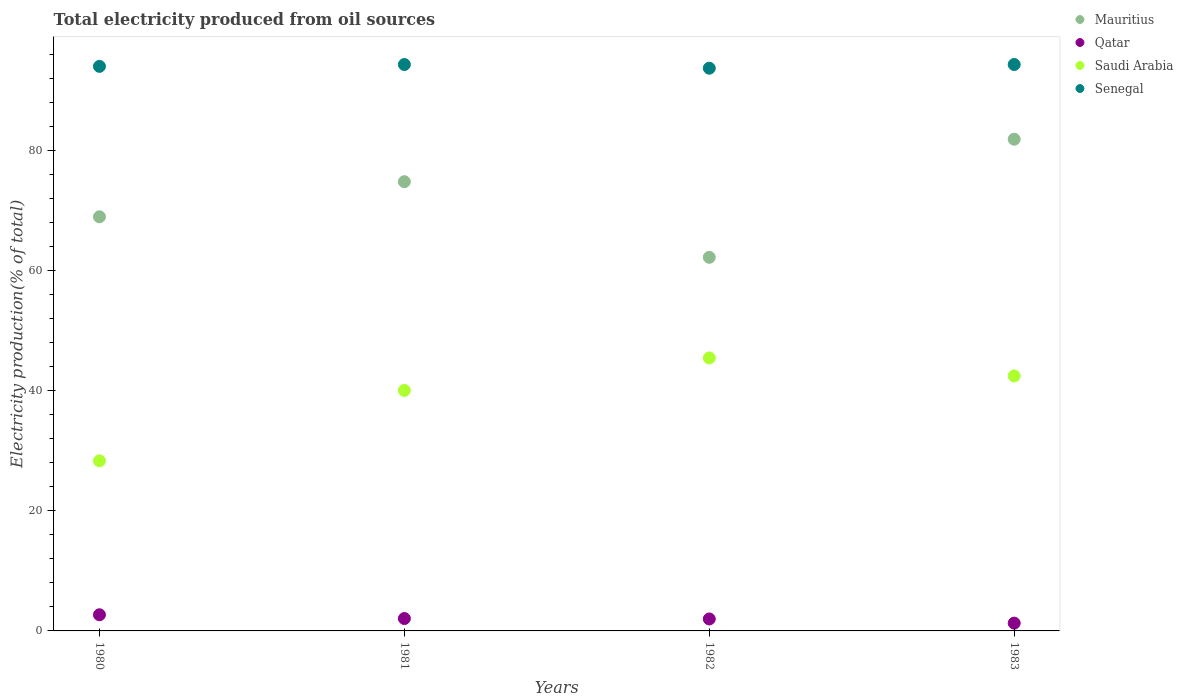Is the number of dotlines equal to the number of legend labels?
Provide a short and direct response. Yes. What is the total electricity produced in Saudi Arabia in 1983?
Provide a succinct answer. 42.49. Across all years, what is the maximum total electricity produced in Mauritius?
Ensure brevity in your answer.  81.94. Across all years, what is the minimum total electricity produced in Saudi Arabia?
Provide a short and direct response. 28.34. In which year was the total electricity produced in Saudi Arabia maximum?
Keep it short and to the point. 1982. What is the total total electricity produced in Saudi Arabia in the graph?
Your answer should be compact. 156.41. What is the difference between the total electricity produced in Saudi Arabia in 1980 and that in 1983?
Your response must be concise. -14.14. What is the difference between the total electricity produced in Saudi Arabia in 1981 and the total electricity produced in Senegal in 1982?
Keep it short and to the point. -53.7. What is the average total electricity produced in Senegal per year?
Provide a succinct answer. 94.16. In the year 1980, what is the difference between the total electricity produced in Saudi Arabia and total electricity produced in Senegal?
Your answer should be very brief. -65.74. In how many years, is the total electricity produced in Mauritius greater than 64 %?
Your answer should be compact. 3. What is the ratio of the total electricity produced in Qatar in 1982 to that in 1983?
Your answer should be compact. 1.54. Is the difference between the total electricity produced in Saudi Arabia in 1981 and 1983 greater than the difference between the total electricity produced in Senegal in 1981 and 1983?
Offer a very short reply. No. What is the difference between the highest and the second highest total electricity produced in Saudi Arabia?
Offer a terse response. 3. What is the difference between the highest and the lowest total electricity produced in Saudi Arabia?
Offer a very short reply. 17.15. In how many years, is the total electricity produced in Saudi Arabia greater than the average total electricity produced in Saudi Arabia taken over all years?
Provide a succinct answer. 3. Is the sum of the total electricity produced in Senegal in 1980 and 1982 greater than the maximum total electricity produced in Mauritius across all years?
Ensure brevity in your answer.  Yes. Is it the case that in every year, the sum of the total electricity produced in Qatar and total electricity produced in Senegal  is greater than the sum of total electricity produced in Mauritius and total electricity produced in Saudi Arabia?
Your answer should be very brief. No. Is it the case that in every year, the sum of the total electricity produced in Senegal and total electricity produced in Saudi Arabia  is greater than the total electricity produced in Qatar?
Offer a terse response. Yes. Does the total electricity produced in Mauritius monotonically increase over the years?
Provide a short and direct response. No. Is the total electricity produced in Mauritius strictly less than the total electricity produced in Qatar over the years?
Your answer should be very brief. No. How many dotlines are there?
Your answer should be very brief. 4. How many years are there in the graph?
Make the answer very short. 4. What is the difference between two consecutive major ticks on the Y-axis?
Provide a succinct answer. 20. Where does the legend appear in the graph?
Your answer should be very brief. Top right. What is the title of the graph?
Offer a terse response. Total electricity produced from oil sources. Does "Bahamas" appear as one of the legend labels in the graph?
Your answer should be compact. No. What is the label or title of the Y-axis?
Your answer should be very brief. Electricity production(% of total). What is the Electricity production(% of total) of Mauritius in 1980?
Ensure brevity in your answer.  69.01. What is the Electricity production(% of total) in Qatar in 1980?
Your answer should be very brief. 2.69. What is the Electricity production(% of total) of Saudi Arabia in 1980?
Your answer should be compact. 28.34. What is the Electricity production(% of total) in Senegal in 1980?
Your answer should be compact. 94.08. What is the Electricity production(% of total) of Mauritius in 1981?
Ensure brevity in your answer.  74.86. What is the Electricity production(% of total) in Qatar in 1981?
Ensure brevity in your answer.  2.07. What is the Electricity production(% of total) of Saudi Arabia in 1981?
Ensure brevity in your answer.  40.08. What is the Electricity production(% of total) of Senegal in 1981?
Offer a terse response. 94.39. What is the Electricity production(% of total) in Mauritius in 1982?
Keep it short and to the point. 62.26. What is the Electricity production(% of total) of Qatar in 1982?
Provide a short and direct response. 1.99. What is the Electricity production(% of total) of Saudi Arabia in 1982?
Provide a short and direct response. 45.49. What is the Electricity production(% of total) of Senegal in 1982?
Your answer should be compact. 93.78. What is the Electricity production(% of total) of Mauritius in 1983?
Ensure brevity in your answer.  81.94. What is the Electricity production(% of total) of Qatar in 1983?
Provide a succinct answer. 1.3. What is the Electricity production(% of total) of Saudi Arabia in 1983?
Offer a very short reply. 42.49. What is the Electricity production(% of total) in Senegal in 1983?
Your answer should be compact. 94.39. Across all years, what is the maximum Electricity production(% of total) of Mauritius?
Offer a terse response. 81.94. Across all years, what is the maximum Electricity production(% of total) in Qatar?
Your response must be concise. 2.69. Across all years, what is the maximum Electricity production(% of total) in Saudi Arabia?
Provide a short and direct response. 45.49. Across all years, what is the maximum Electricity production(% of total) of Senegal?
Give a very brief answer. 94.39. Across all years, what is the minimum Electricity production(% of total) of Mauritius?
Offer a very short reply. 62.26. Across all years, what is the minimum Electricity production(% of total) in Qatar?
Keep it short and to the point. 1.3. Across all years, what is the minimum Electricity production(% of total) in Saudi Arabia?
Give a very brief answer. 28.34. Across all years, what is the minimum Electricity production(% of total) of Senegal?
Offer a very short reply. 93.78. What is the total Electricity production(% of total) of Mauritius in the graph?
Provide a short and direct response. 288.08. What is the total Electricity production(% of total) of Qatar in the graph?
Make the answer very short. 8.05. What is the total Electricity production(% of total) of Saudi Arabia in the graph?
Your answer should be very brief. 156.41. What is the total Electricity production(% of total) of Senegal in the graph?
Your response must be concise. 376.64. What is the difference between the Electricity production(% of total) in Mauritius in 1980 and that in 1981?
Make the answer very short. -5.85. What is the difference between the Electricity production(% of total) in Qatar in 1980 and that in 1981?
Keep it short and to the point. 0.62. What is the difference between the Electricity production(% of total) in Saudi Arabia in 1980 and that in 1981?
Provide a short and direct response. -11.74. What is the difference between the Electricity production(% of total) of Senegal in 1980 and that in 1981?
Make the answer very short. -0.31. What is the difference between the Electricity production(% of total) of Mauritius in 1980 and that in 1982?
Offer a terse response. 6.76. What is the difference between the Electricity production(% of total) of Qatar in 1980 and that in 1982?
Provide a succinct answer. 0.7. What is the difference between the Electricity production(% of total) of Saudi Arabia in 1980 and that in 1982?
Give a very brief answer. -17.15. What is the difference between the Electricity production(% of total) of Senegal in 1980 and that in 1982?
Provide a short and direct response. 0.31. What is the difference between the Electricity production(% of total) in Mauritius in 1980 and that in 1983?
Keep it short and to the point. -12.93. What is the difference between the Electricity production(% of total) of Qatar in 1980 and that in 1983?
Your response must be concise. 1.39. What is the difference between the Electricity production(% of total) in Saudi Arabia in 1980 and that in 1983?
Provide a short and direct response. -14.14. What is the difference between the Electricity production(% of total) of Senegal in 1980 and that in 1983?
Your answer should be compact. -0.31. What is the difference between the Electricity production(% of total) in Mauritius in 1981 and that in 1982?
Offer a terse response. 12.6. What is the difference between the Electricity production(% of total) in Qatar in 1981 and that in 1982?
Your answer should be very brief. 0.07. What is the difference between the Electricity production(% of total) in Saudi Arabia in 1981 and that in 1982?
Your response must be concise. -5.41. What is the difference between the Electricity production(% of total) of Senegal in 1981 and that in 1982?
Your response must be concise. 0.61. What is the difference between the Electricity production(% of total) in Mauritius in 1981 and that in 1983?
Your response must be concise. -7.08. What is the difference between the Electricity production(% of total) in Qatar in 1981 and that in 1983?
Offer a very short reply. 0.77. What is the difference between the Electricity production(% of total) in Saudi Arabia in 1981 and that in 1983?
Provide a short and direct response. -2.41. What is the difference between the Electricity production(% of total) in Senegal in 1981 and that in 1983?
Offer a very short reply. -0. What is the difference between the Electricity production(% of total) of Mauritius in 1982 and that in 1983?
Provide a short and direct response. -19.68. What is the difference between the Electricity production(% of total) of Qatar in 1982 and that in 1983?
Keep it short and to the point. 0.7. What is the difference between the Electricity production(% of total) of Saudi Arabia in 1982 and that in 1983?
Provide a succinct answer. 3. What is the difference between the Electricity production(% of total) in Senegal in 1982 and that in 1983?
Provide a short and direct response. -0.61. What is the difference between the Electricity production(% of total) of Mauritius in 1980 and the Electricity production(% of total) of Qatar in 1981?
Offer a terse response. 66.95. What is the difference between the Electricity production(% of total) of Mauritius in 1980 and the Electricity production(% of total) of Saudi Arabia in 1981?
Offer a very short reply. 28.93. What is the difference between the Electricity production(% of total) in Mauritius in 1980 and the Electricity production(% of total) in Senegal in 1981?
Your answer should be compact. -25.38. What is the difference between the Electricity production(% of total) in Qatar in 1980 and the Electricity production(% of total) in Saudi Arabia in 1981?
Make the answer very short. -37.39. What is the difference between the Electricity production(% of total) of Qatar in 1980 and the Electricity production(% of total) of Senegal in 1981?
Provide a short and direct response. -91.7. What is the difference between the Electricity production(% of total) of Saudi Arabia in 1980 and the Electricity production(% of total) of Senegal in 1981?
Give a very brief answer. -66.05. What is the difference between the Electricity production(% of total) in Mauritius in 1980 and the Electricity production(% of total) in Qatar in 1982?
Give a very brief answer. 67.02. What is the difference between the Electricity production(% of total) of Mauritius in 1980 and the Electricity production(% of total) of Saudi Arabia in 1982?
Provide a short and direct response. 23.52. What is the difference between the Electricity production(% of total) in Mauritius in 1980 and the Electricity production(% of total) in Senegal in 1982?
Your response must be concise. -24.76. What is the difference between the Electricity production(% of total) in Qatar in 1980 and the Electricity production(% of total) in Saudi Arabia in 1982?
Make the answer very short. -42.8. What is the difference between the Electricity production(% of total) of Qatar in 1980 and the Electricity production(% of total) of Senegal in 1982?
Keep it short and to the point. -91.09. What is the difference between the Electricity production(% of total) of Saudi Arabia in 1980 and the Electricity production(% of total) of Senegal in 1982?
Keep it short and to the point. -65.43. What is the difference between the Electricity production(% of total) of Mauritius in 1980 and the Electricity production(% of total) of Qatar in 1983?
Your answer should be compact. 67.72. What is the difference between the Electricity production(% of total) of Mauritius in 1980 and the Electricity production(% of total) of Saudi Arabia in 1983?
Your answer should be very brief. 26.52. What is the difference between the Electricity production(% of total) of Mauritius in 1980 and the Electricity production(% of total) of Senegal in 1983?
Give a very brief answer. -25.38. What is the difference between the Electricity production(% of total) in Qatar in 1980 and the Electricity production(% of total) in Saudi Arabia in 1983?
Make the answer very short. -39.8. What is the difference between the Electricity production(% of total) in Qatar in 1980 and the Electricity production(% of total) in Senegal in 1983?
Provide a succinct answer. -91.7. What is the difference between the Electricity production(% of total) of Saudi Arabia in 1980 and the Electricity production(% of total) of Senegal in 1983?
Offer a terse response. -66.05. What is the difference between the Electricity production(% of total) of Mauritius in 1981 and the Electricity production(% of total) of Qatar in 1982?
Your answer should be very brief. 72.87. What is the difference between the Electricity production(% of total) of Mauritius in 1981 and the Electricity production(% of total) of Saudi Arabia in 1982?
Your answer should be very brief. 29.37. What is the difference between the Electricity production(% of total) in Mauritius in 1981 and the Electricity production(% of total) in Senegal in 1982?
Give a very brief answer. -18.92. What is the difference between the Electricity production(% of total) in Qatar in 1981 and the Electricity production(% of total) in Saudi Arabia in 1982?
Provide a short and direct response. -43.42. What is the difference between the Electricity production(% of total) of Qatar in 1981 and the Electricity production(% of total) of Senegal in 1982?
Give a very brief answer. -91.71. What is the difference between the Electricity production(% of total) of Saudi Arabia in 1981 and the Electricity production(% of total) of Senegal in 1982?
Keep it short and to the point. -53.7. What is the difference between the Electricity production(% of total) of Mauritius in 1981 and the Electricity production(% of total) of Qatar in 1983?
Your response must be concise. 73.56. What is the difference between the Electricity production(% of total) of Mauritius in 1981 and the Electricity production(% of total) of Saudi Arabia in 1983?
Offer a very short reply. 32.37. What is the difference between the Electricity production(% of total) of Mauritius in 1981 and the Electricity production(% of total) of Senegal in 1983?
Your response must be concise. -19.53. What is the difference between the Electricity production(% of total) of Qatar in 1981 and the Electricity production(% of total) of Saudi Arabia in 1983?
Provide a short and direct response. -40.42. What is the difference between the Electricity production(% of total) in Qatar in 1981 and the Electricity production(% of total) in Senegal in 1983?
Your response must be concise. -92.33. What is the difference between the Electricity production(% of total) of Saudi Arabia in 1981 and the Electricity production(% of total) of Senegal in 1983?
Provide a succinct answer. -54.31. What is the difference between the Electricity production(% of total) in Mauritius in 1982 and the Electricity production(% of total) in Qatar in 1983?
Your answer should be very brief. 60.96. What is the difference between the Electricity production(% of total) of Mauritius in 1982 and the Electricity production(% of total) of Saudi Arabia in 1983?
Give a very brief answer. 19.77. What is the difference between the Electricity production(% of total) of Mauritius in 1982 and the Electricity production(% of total) of Senegal in 1983?
Provide a short and direct response. -32.13. What is the difference between the Electricity production(% of total) of Qatar in 1982 and the Electricity production(% of total) of Saudi Arabia in 1983?
Keep it short and to the point. -40.5. What is the difference between the Electricity production(% of total) of Qatar in 1982 and the Electricity production(% of total) of Senegal in 1983?
Give a very brief answer. -92.4. What is the difference between the Electricity production(% of total) of Saudi Arabia in 1982 and the Electricity production(% of total) of Senegal in 1983?
Offer a very short reply. -48.9. What is the average Electricity production(% of total) in Mauritius per year?
Offer a terse response. 72.02. What is the average Electricity production(% of total) of Qatar per year?
Your answer should be compact. 2.01. What is the average Electricity production(% of total) of Saudi Arabia per year?
Your answer should be compact. 39.1. What is the average Electricity production(% of total) in Senegal per year?
Give a very brief answer. 94.16. In the year 1980, what is the difference between the Electricity production(% of total) in Mauritius and Electricity production(% of total) in Qatar?
Give a very brief answer. 66.32. In the year 1980, what is the difference between the Electricity production(% of total) in Mauritius and Electricity production(% of total) in Saudi Arabia?
Provide a succinct answer. 40.67. In the year 1980, what is the difference between the Electricity production(% of total) of Mauritius and Electricity production(% of total) of Senegal?
Your answer should be very brief. -25.07. In the year 1980, what is the difference between the Electricity production(% of total) of Qatar and Electricity production(% of total) of Saudi Arabia?
Your answer should be compact. -25.65. In the year 1980, what is the difference between the Electricity production(% of total) in Qatar and Electricity production(% of total) in Senegal?
Give a very brief answer. -91.39. In the year 1980, what is the difference between the Electricity production(% of total) of Saudi Arabia and Electricity production(% of total) of Senegal?
Your response must be concise. -65.74. In the year 1981, what is the difference between the Electricity production(% of total) of Mauritius and Electricity production(% of total) of Qatar?
Your answer should be very brief. 72.79. In the year 1981, what is the difference between the Electricity production(% of total) in Mauritius and Electricity production(% of total) in Saudi Arabia?
Offer a very short reply. 34.78. In the year 1981, what is the difference between the Electricity production(% of total) of Mauritius and Electricity production(% of total) of Senegal?
Provide a short and direct response. -19.53. In the year 1981, what is the difference between the Electricity production(% of total) in Qatar and Electricity production(% of total) in Saudi Arabia?
Give a very brief answer. -38.01. In the year 1981, what is the difference between the Electricity production(% of total) in Qatar and Electricity production(% of total) in Senegal?
Give a very brief answer. -92.32. In the year 1981, what is the difference between the Electricity production(% of total) of Saudi Arabia and Electricity production(% of total) of Senegal?
Your response must be concise. -54.31. In the year 1982, what is the difference between the Electricity production(% of total) in Mauritius and Electricity production(% of total) in Qatar?
Your answer should be very brief. 60.26. In the year 1982, what is the difference between the Electricity production(% of total) in Mauritius and Electricity production(% of total) in Saudi Arabia?
Provide a short and direct response. 16.77. In the year 1982, what is the difference between the Electricity production(% of total) of Mauritius and Electricity production(% of total) of Senegal?
Provide a short and direct response. -31.52. In the year 1982, what is the difference between the Electricity production(% of total) in Qatar and Electricity production(% of total) in Saudi Arabia?
Provide a succinct answer. -43.5. In the year 1982, what is the difference between the Electricity production(% of total) of Qatar and Electricity production(% of total) of Senegal?
Ensure brevity in your answer.  -91.78. In the year 1982, what is the difference between the Electricity production(% of total) in Saudi Arabia and Electricity production(% of total) in Senegal?
Offer a terse response. -48.29. In the year 1983, what is the difference between the Electricity production(% of total) of Mauritius and Electricity production(% of total) of Qatar?
Provide a short and direct response. 80.64. In the year 1983, what is the difference between the Electricity production(% of total) in Mauritius and Electricity production(% of total) in Saudi Arabia?
Your answer should be compact. 39.45. In the year 1983, what is the difference between the Electricity production(% of total) in Mauritius and Electricity production(% of total) in Senegal?
Ensure brevity in your answer.  -12.45. In the year 1983, what is the difference between the Electricity production(% of total) of Qatar and Electricity production(% of total) of Saudi Arabia?
Your response must be concise. -41.19. In the year 1983, what is the difference between the Electricity production(% of total) in Qatar and Electricity production(% of total) in Senegal?
Your answer should be very brief. -93.09. In the year 1983, what is the difference between the Electricity production(% of total) in Saudi Arabia and Electricity production(% of total) in Senegal?
Offer a terse response. -51.9. What is the ratio of the Electricity production(% of total) of Mauritius in 1980 to that in 1981?
Offer a very short reply. 0.92. What is the ratio of the Electricity production(% of total) in Qatar in 1980 to that in 1981?
Keep it short and to the point. 1.3. What is the ratio of the Electricity production(% of total) in Saudi Arabia in 1980 to that in 1981?
Offer a very short reply. 0.71. What is the ratio of the Electricity production(% of total) of Mauritius in 1980 to that in 1982?
Give a very brief answer. 1.11. What is the ratio of the Electricity production(% of total) in Qatar in 1980 to that in 1982?
Provide a short and direct response. 1.35. What is the ratio of the Electricity production(% of total) in Saudi Arabia in 1980 to that in 1982?
Your answer should be very brief. 0.62. What is the ratio of the Electricity production(% of total) of Senegal in 1980 to that in 1982?
Make the answer very short. 1. What is the ratio of the Electricity production(% of total) in Mauritius in 1980 to that in 1983?
Your answer should be very brief. 0.84. What is the ratio of the Electricity production(% of total) in Qatar in 1980 to that in 1983?
Provide a succinct answer. 2.07. What is the ratio of the Electricity production(% of total) in Saudi Arabia in 1980 to that in 1983?
Your response must be concise. 0.67. What is the ratio of the Electricity production(% of total) of Senegal in 1980 to that in 1983?
Provide a succinct answer. 1. What is the ratio of the Electricity production(% of total) of Mauritius in 1981 to that in 1982?
Provide a short and direct response. 1.2. What is the ratio of the Electricity production(% of total) of Qatar in 1981 to that in 1982?
Keep it short and to the point. 1.04. What is the ratio of the Electricity production(% of total) in Saudi Arabia in 1981 to that in 1982?
Ensure brevity in your answer.  0.88. What is the ratio of the Electricity production(% of total) of Senegal in 1981 to that in 1982?
Provide a succinct answer. 1.01. What is the ratio of the Electricity production(% of total) in Mauritius in 1981 to that in 1983?
Provide a short and direct response. 0.91. What is the ratio of the Electricity production(% of total) in Qatar in 1981 to that in 1983?
Your response must be concise. 1.59. What is the ratio of the Electricity production(% of total) of Saudi Arabia in 1981 to that in 1983?
Your response must be concise. 0.94. What is the ratio of the Electricity production(% of total) of Senegal in 1981 to that in 1983?
Give a very brief answer. 1. What is the ratio of the Electricity production(% of total) in Mauritius in 1982 to that in 1983?
Keep it short and to the point. 0.76. What is the ratio of the Electricity production(% of total) of Qatar in 1982 to that in 1983?
Keep it short and to the point. 1.54. What is the ratio of the Electricity production(% of total) of Saudi Arabia in 1982 to that in 1983?
Offer a very short reply. 1.07. What is the difference between the highest and the second highest Electricity production(% of total) of Mauritius?
Your answer should be compact. 7.08. What is the difference between the highest and the second highest Electricity production(% of total) in Qatar?
Provide a short and direct response. 0.62. What is the difference between the highest and the second highest Electricity production(% of total) of Saudi Arabia?
Make the answer very short. 3. What is the difference between the highest and the second highest Electricity production(% of total) of Senegal?
Give a very brief answer. 0. What is the difference between the highest and the lowest Electricity production(% of total) of Mauritius?
Your response must be concise. 19.68. What is the difference between the highest and the lowest Electricity production(% of total) in Qatar?
Ensure brevity in your answer.  1.39. What is the difference between the highest and the lowest Electricity production(% of total) in Saudi Arabia?
Ensure brevity in your answer.  17.15. What is the difference between the highest and the lowest Electricity production(% of total) of Senegal?
Keep it short and to the point. 0.61. 